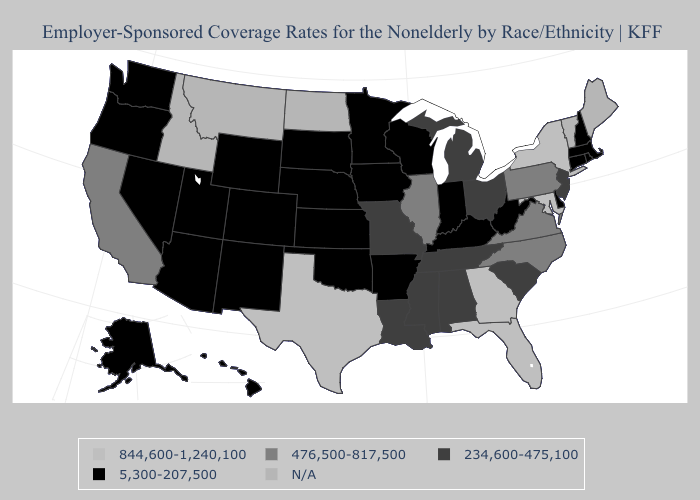Name the states that have a value in the range 234,600-475,100?
Concise answer only. Alabama, Louisiana, Michigan, Mississippi, Missouri, New Jersey, Ohio, South Carolina, Tennessee. What is the lowest value in the USA?
Give a very brief answer. 5,300-207,500. What is the lowest value in states that border Missouri?
Give a very brief answer. 5,300-207,500. Name the states that have a value in the range 234,600-475,100?
Be succinct. Alabama, Louisiana, Michigan, Mississippi, Missouri, New Jersey, Ohio, South Carolina, Tennessee. What is the lowest value in the Northeast?
Write a very short answer. 5,300-207,500. Which states have the lowest value in the USA?
Concise answer only. Alaska, Arizona, Arkansas, Colorado, Connecticut, Delaware, Hawaii, Indiana, Iowa, Kansas, Kentucky, Massachusetts, Minnesota, Nebraska, Nevada, New Hampshire, New Mexico, Oklahoma, Oregon, Rhode Island, South Dakota, Utah, Washington, West Virginia, Wisconsin, Wyoming. What is the value of Montana?
Concise answer only. N/A. Name the states that have a value in the range 5,300-207,500?
Keep it brief. Alaska, Arizona, Arkansas, Colorado, Connecticut, Delaware, Hawaii, Indiana, Iowa, Kansas, Kentucky, Massachusetts, Minnesota, Nebraska, Nevada, New Hampshire, New Mexico, Oklahoma, Oregon, Rhode Island, South Dakota, Utah, Washington, West Virginia, Wisconsin, Wyoming. Name the states that have a value in the range 5,300-207,500?
Keep it brief. Alaska, Arizona, Arkansas, Colorado, Connecticut, Delaware, Hawaii, Indiana, Iowa, Kansas, Kentucky, Massachusetts, Minnesota, Nebraska, Nevada, New Hampshire, New Mexico, Oklahoma, Oregon, Rhode Island, South Dakota, Utah, Washington, West Virginia, Wisconsin, Wyoming. Among the states that border Rhode Island , which have the highest value?
Be succinct. Connecticut, Massachusetts. What is the lowest value in the MidWest?
Write a very short answer. 5,300-207,500. Name the states that have a value in the range 5,300-207,500?
Write a very short answer. Alaska, Arizona, Arkansas, Colorado, Connecticut, Delaware, Hawaii, Indiana, Iowa, Kansas, Kentucky, Massachusetts, Minnesota, Nebraska, Nevada, New Hampshire, New Mexico, Oklahoma, Oregon, Rhode Island, South Dakota, Utah, Washington, West Virginia, Wisconsin, Wyoming. Name the states that have a value in the range 5,300-207,500?
Answer briefly. Alaska, Arizona, Arkansas, Colorado, Connecticut, Delaware, Hawaii, Indiana, Iowa, Kansas, Kentucky, Massachusetts, Minnesota, Nebraska, Nevada, New Hampshire, New Mexico, Oklahoma, Oregon, Rhode Island, South Dakota, Utah, Washington, West Virginia, Wisconsin, Wyoming. What is the value of Indiana?
Be succinct. 5,300-207,500. 